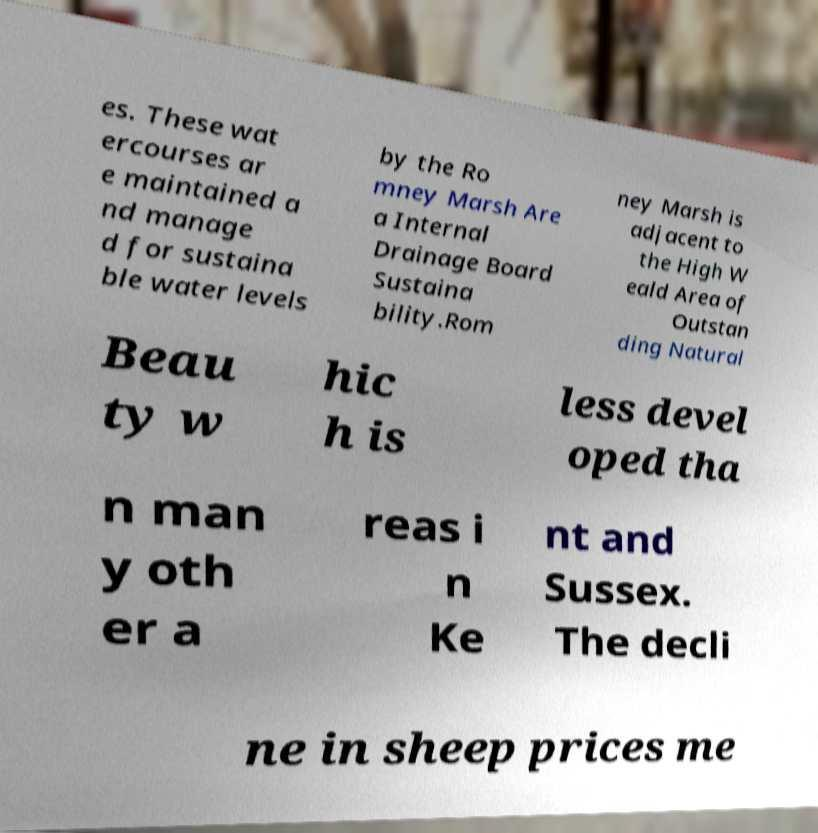I need the written content from this picture converted into text. Can you do that? es. These wat ercourses ar e maintained a nd manage d for sustaina ble water levels by the Ro mney Marsh Are a Internal Drainage Board Sustaina bility.Rom ney Marsh is adjacent to the High W eald Area of Outstan ding Natural Beau ty w hic h is less devel oped tha n man y oth er a reas i n Ke nt and Sussex. The decli ne in sheep prices me 